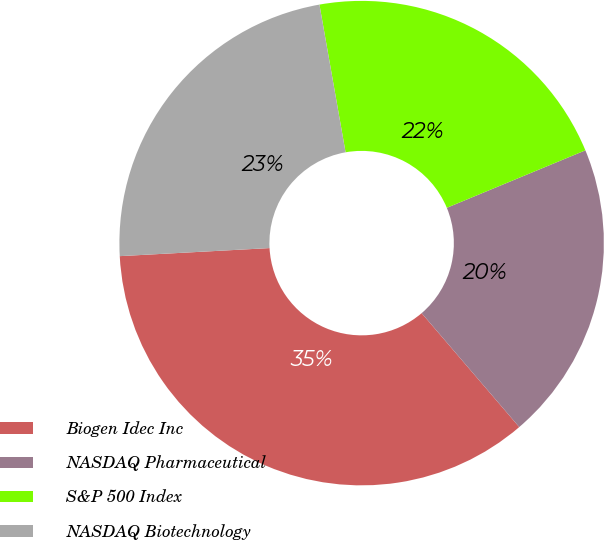<chart> <loc_0><loc_0><loc_500><loc_500><pie_chart><fcel>Biogen Idec Inc<fcel>NASDAQ Pharmaceutical<fcel>S&P 500 Index<fcel>NASDAQ Biotechnology<nl><fcel>35.42%<fcel>19.98%<fcel>21.53%<fcel>23.07%<nl></chart> 